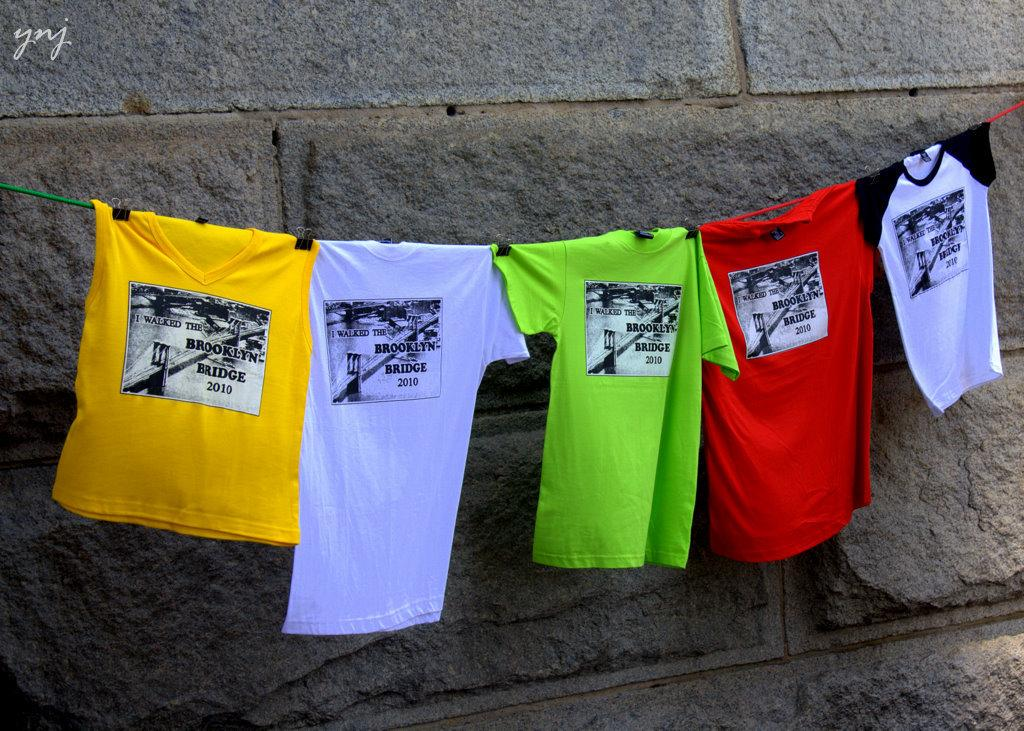<image>
Share a concise interpretation of the image provided. a lot of colorful teeshirts with Brooklyn Bridge written on the front. 